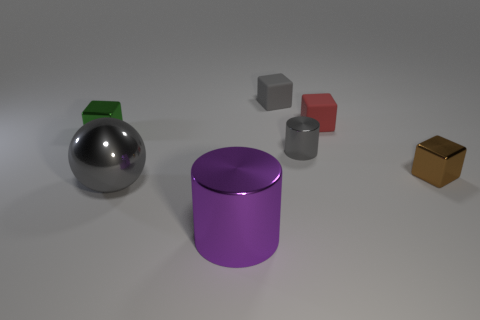Subtract 1 blocks. How many blocks are left? 3 Add 3 small gray matte objects. How many objects exist? 10 Subtract all balls. How many objects are left? 6 Subtract 0 cyan cylinders. How many objects are left? 7 Subtract all small cyan matte spheres. Subtract all small shiny things. How many objects are left? 4 Add 5 big metal objects. How many big metal objects are left? 7 Add 1 cubes. How many cubes exist? 5 